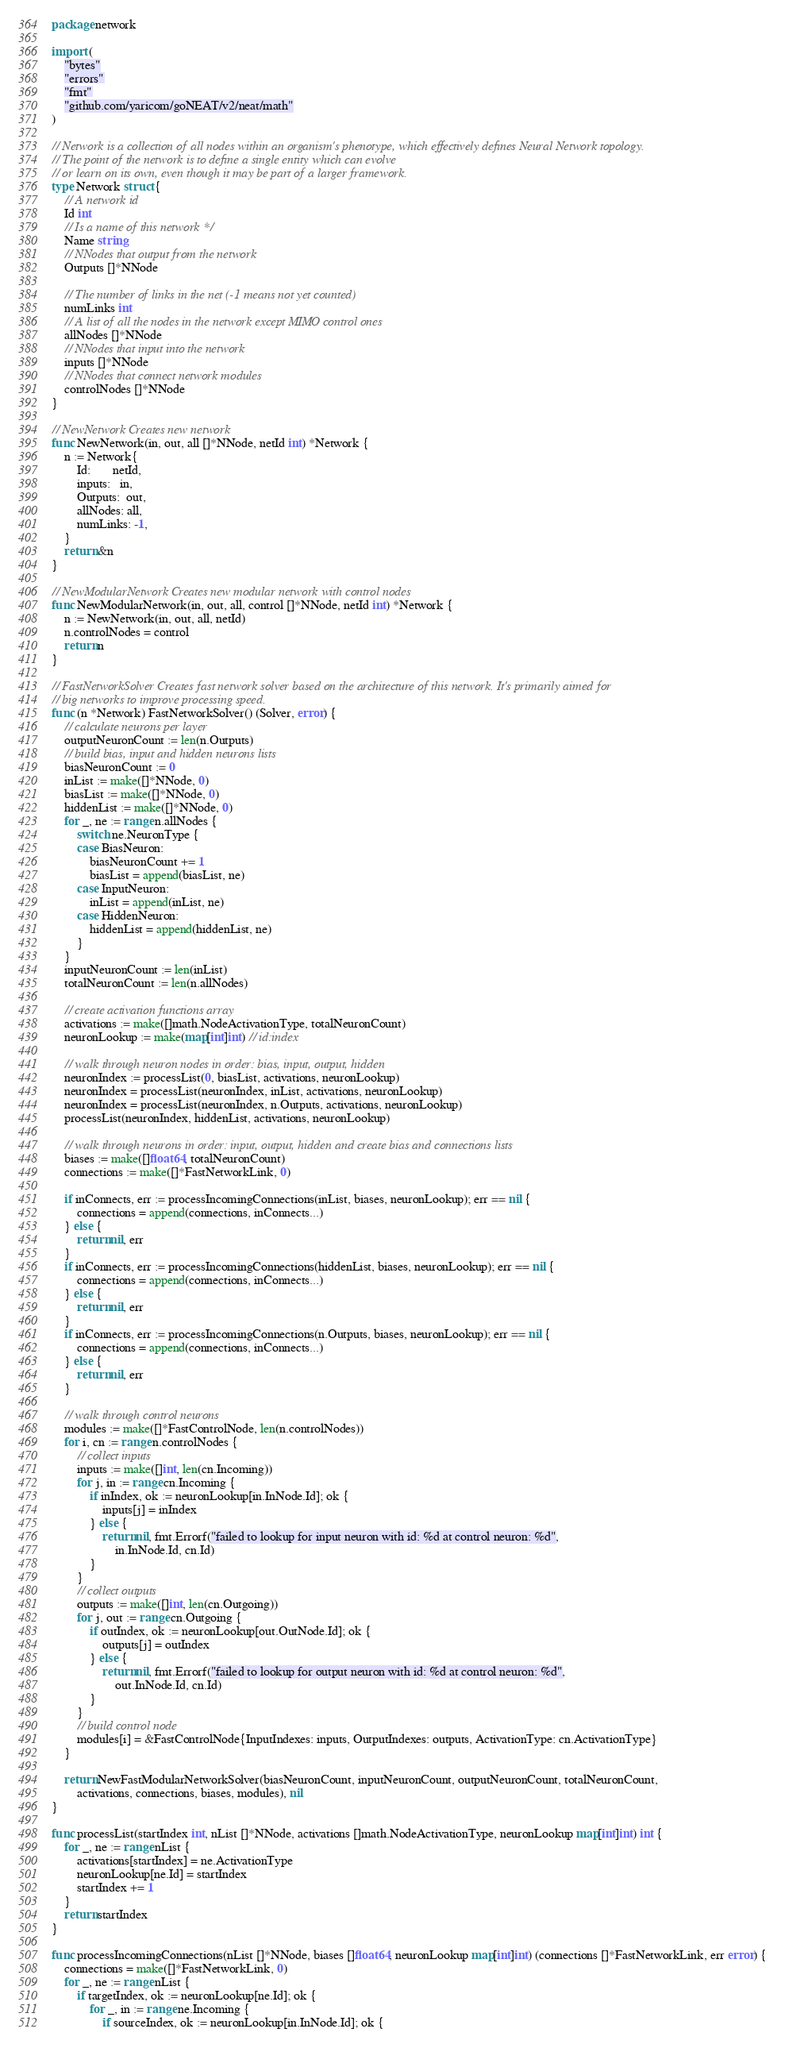<code> <loc_0><loc_0><loc_500><loc_500><_Go_>package network

import (
	"bytes"
	"errors"
	"fmt"
	"github.com/yaricom/goNEAT/v2/neat/math"
)

// Network is a collection of all nodes within an organism's phenotype, which effectively defines Neural Network topology.
// The point of the network is to define a single entity which can evolve
// or learn on its own, even though it may be part of a larger framework.
type Network struct {
	// A network id
	Id int
	// Is a name of this network */
	Name string
	// NNodes that output from the network
	Outputs []*NNode

	// The number of links in the net (-1 means not yet counted)
	numLinks int
	// A list of all the nodes in the network except MIMO control ones
	allNodes []*NNode
	// NNodes that input into the network
	inputs []*NNode
	// NNodes that connect network modules
	controlNodes []*NNode
}

// NewNetwork Creates new network
func NewNetwork(in, out, all []*NNode, netId int) *Network {
	n := Network{
		Id:       netId,
		inputs:   in,
		Outputs:  out,
		allNodes: all,
		numLinks: -1,
	}
	return &n
}

// NewModularNetwork Creates new modular network with control nodes
func NewModularNetwork(in, out, all, control []*NNode, netId int) *Network {
	n := NewNetwork(in, out, all, netId)
	n.controlNodes = control
	return n
}

// FastNetworkSolver Creates fast network solver based on the architecture of this network. It's primarily aimed for
// big networks to improve processing speed.
func (n *Network) FastNetworkSolver() (Solver, error) {
	// calculate neurons per layer
	outputNeuronCount := len(n.Outputs)
	// build bias, input and hidden neurons lists
	biasNeuronCount := 0
	inList := make([]*NNode, 0)
	biasList := make([]*NNode, 0)
	hiddenList := make([]*NNode, 0)
	for _, ne := range n.allNodes {
		switch ne.NeuronType {
		case BiasNeuron:
			biasNeuronCount += 1
			biasList = append(biasList, ne)
		case InputNeuron:
			inList = append(inList, ne)
		case HiddenNeuron:
			hiddenList = append(hiddenList, ne)
		}
	}
	inputNeuronCount := len(inList)
	totalNeuronCount := len(n.allNodes)

	// create activation functions array
	activations := make([]math.NodeActivationType, totalNeuronCount)
	neuronLookup := make(map[int]int) // id:index

	// walk through neuron nodes in order: bias, input, output, hidden
	neuronIndex := processList(0, biasList, activations, neuronLookup)
	neuronIndex = processList(neuronIndex, inList, activations, neuronLookup)
	neuronIndex = processList(neuronIndex, n.Outputs, activations, neuronLookup)
	processList(neuronIndex, hiddenList, activations, neuronLookup)

	// walk through neurons in order: input, output, hidden and create bias and connections lists
	biases := make([]float64, totalNeuronCount)
	connections := make([]*FastNetworkLink, 0)

	if inConnects, err := processIncomingConnections(inList, biases, neuronLookup); err == nil {
		connections = append(connections, inConnects...)
	} else {
		return nil, err
	}
	if inConnects, err := processIncomingConnections(hiddenList, biases, neuronLookup); err == nil {
		connections = append(connections, inConnects...)
	} else {
		return nil, err
	}
	if inConnects, err := processIncomingConnections(n.Outputs, biases, neuronLookup); err == nil {
		connections = append(connections, inConnects...)
	} else {
		return nil, err
	}

	// walk through control neurons
	modules := make([]*FastControlNode, len(n.controlNodes))
	for i, cn := range n.controlNodes {
		// collect inputs
		inputs := make([]int, len(cn.Incoming))
		for j, in := range cn.Incoming {
			if inIndex, ok := neuronLookup[in.InNode.Id]; ok {
				inputs[j] = inIndex
			} else {
				return nil, fmt.Errorf("failed to lookup for input neuron with id: %d at control neuron: %d",
					in.InNode.Id, cn.Id)
			}
		}
		// collect outputs
		outputs := make([]int, len(cn.Outgoing))
		for j, out := range cn.Outgoing {
			if outIndex, ok := neuronLookup[out.OutNode.Id]; ok {
				outputs[j] = outIndex
			} else {
				return nil, fmt.Errorf("failed to lookup for output neuron with id: %d at control neuron: %d",
					out.InNode.Id, cn.Id)
			}
		}
		// build control node
		modules[i] = &FastControlNode{InputIndexes: inputs, OutputIndexes: outputs, ActivationType: cn.ActivationType}
	}

	return NewFastModularNetworkSolver(biasNeuronCount, inputNeuronCount, outputNeuronCount, totalNeuronCount,
		activations, connections, biases, modules), nil
}

func processList(startIndex int, nList []*NNode, activations []math.NodeActivationType, neuronLookup map[int]int) int {
	for _, ne := range nList {
		activations[startIndex] = ne.ActivationType
		neuronLookup[ne.Id] = startIndex
		startIndex += 1
	}
	return startIndex
}

func processIncomingConnections(nList []*NNode, biases []float64, neuronLookup map[int]int) (connections []*FastNetworkLink, err error) {
	connections = make([]*FastNetworkLink, 0)
	for _, ne := range nList {
		if targetIndex, ok := neuronLookup[ne.Id]; ok {
			for _, in := range ne.Incoming {
				if sourceIndex, ok := neuronLookup[in.InNode.Id]; ok {</code> 